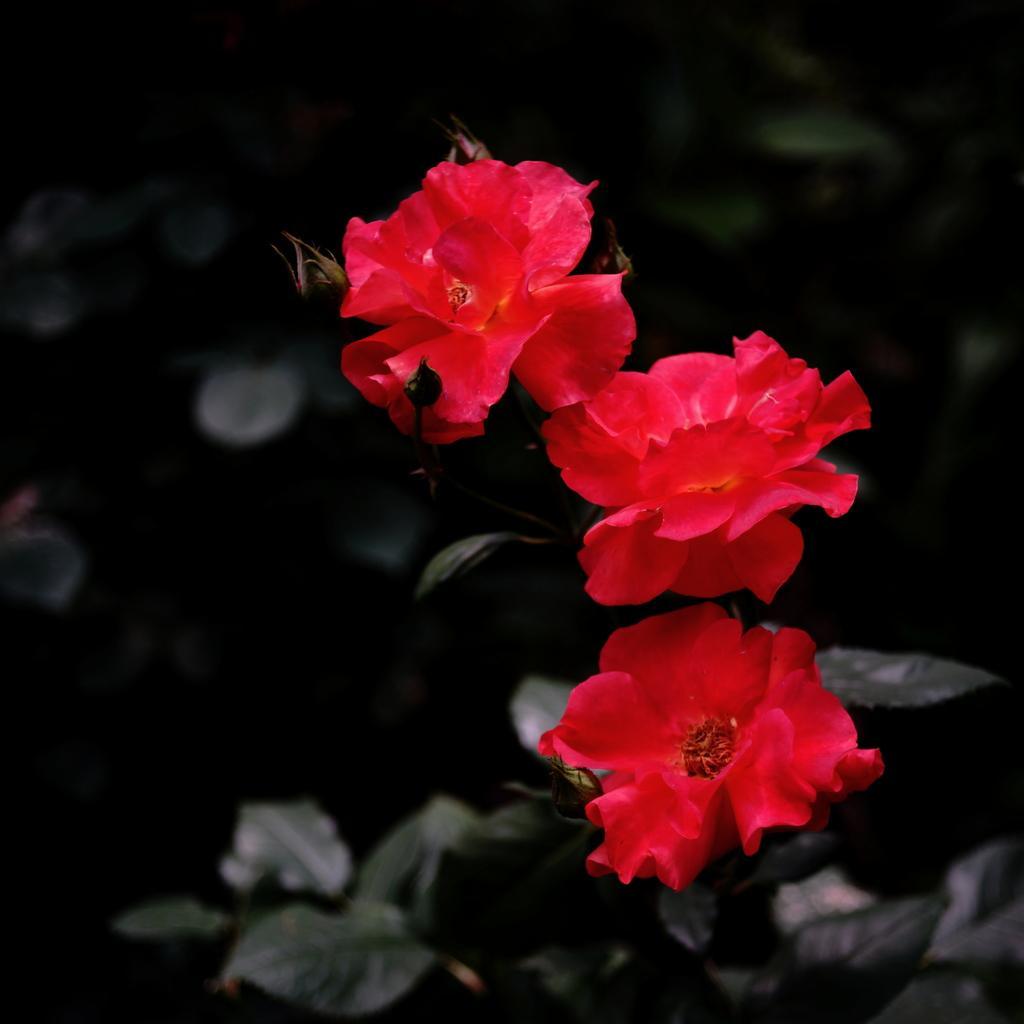In one or two sentences, can you explain what this image depicts? In this image we can see there are three red flowers in the middle. In the background there are leaves. 